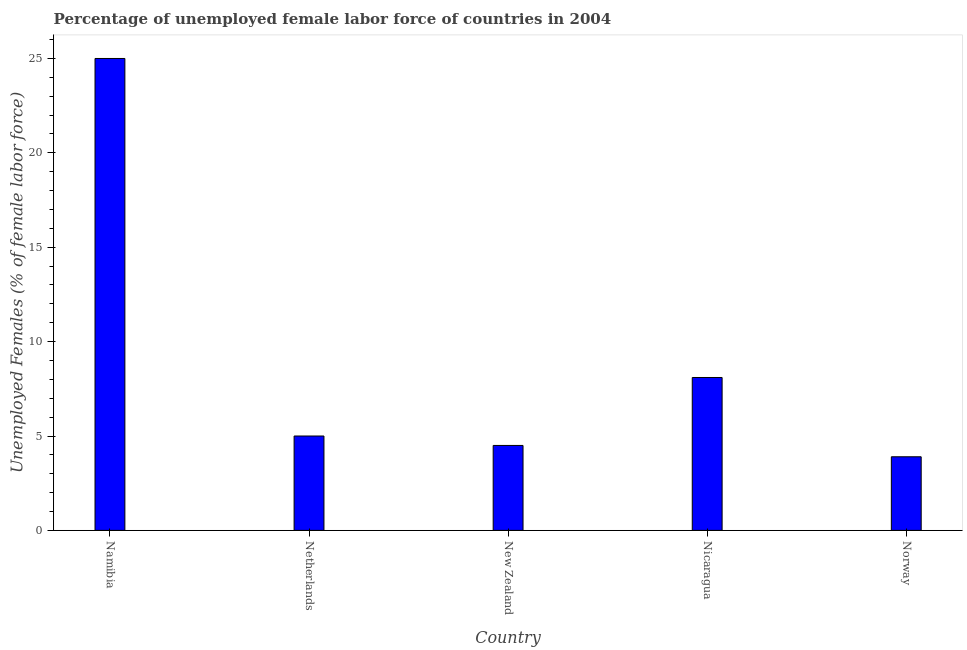Does the graph contain any zero values?
Make the answer very short. No. Does the graph contain grids?
Make the answer very short. No. What is the title of the graph?
Provide a short and direct response. Percentage of unemployed female labor force of countries in 2004. What is the label or title of the X-axis?
Keep it short and to the point. Country. What is the label or title of the Y-axis?
Give a very brief answer. Unemployed Females (% of female labor force). Across all countries, what is the minimum total unemployed female labour force?
Your answer should be very brief. 3.9. In which country was the total unemployed female labour force maximum?
Keep it short and to the point. Namibia. In which country was the total unemployed female labour force minimum?
Your answer should be compact. Norway. What is the sum of the total unemployed female labour force?
Provide a succinct answer. 46.5. What is the difference between the total unemployed female labour force in Netherlands and Norway?
Keep it short and to the point. 1.1. In how many countries, is the total unemployed female labour force greater than 11 %?
Your answer should be very brief. 1. What is the ratio of the total unemployed female labour force in Netherlands to that in Nicaragua?
Your answer should be compact. 0.62. Is the total unemployed female labour force in Netherlands less than that in New Zealand?
Your answer should be compact. No. What is the difference between the highest and the lowest total unemployed female labour force?
Your answer should be very brief. 21.1. In how many countries, is the total unemployed female labour force greater than the average total unemployed female labour force taken over all countries?
Your answer should be very brief. 1. How many bars are there?
Keep it short and to the point. 5. What is the Unemployed Females (% of female labor force) in Namibia?
Provide a succinct answer. 25. What is the Unemployed Females (% of female labor force) of Netherlands?
Your answer should be compact. 5. What is the Unemployed Females (% of female labor force) in New Zealand?
Make the answer very short. 4.5. What is the Unemployed Females (% of female labor force) in Nicaragua?
Offer a very short reply. 8.1. What is the Unemployed Females (% of female labor force) in Norway?
Provide a succinct answer. 3.9. What is the difference between the Unemployed Females (% of female labor force) in Namibia and Netherlands?
Provide a succinct answer. 20. What is the difference between the Unemployed Females (% of female labor force) in Namibia and Nicaragua?
Make the answer very short. 16.9. What is the difference between the Unemployed Females (% of female labor force) in Namibia and Norway?
Provide a succinct answer. 21.1. What is the difference between the Unemployed Females (% of female labor force) in Netherlands and Nicaragua?
Offer a terse response. -3.1. What is the difference between the Unemployed Females (% of female labor force) in Netherlands and Norway?
Provide a short and direct response. 1.1. What is the difference between the Unemployed Females (% of female labor force) in New Zealand and Nicaragua?
Keep it short and to the point. -3.6. What is the ratio of the Unemployed Females (% of female labor force) in Namibia to that in Netherlands?
Your answer should be compact. 5. What is the ratio of the Unemployed Females (% of female labor force) in Namibia to that in New Zealand?
Your answer should be very brief. 5.56. What is the ratio of the Unemployed Females (% of female labor force) in Namibia to that in Nicaragua?
Keep it short and to the point. 3.09. What is the ratio of the Unemployed Females (% of female labor force) in Namibia to that in Norway?
Your answer should be very brief. 6.41. What is the ratio of the Unemployed Females (% of female labor force) in Netherlands to that in New Zealand?
Your answer should be compact. 1.11. What is the ratio of the Unemployed Females (% of female labor force) in Netherlands to that in Nicaragua?
Offer a very short reply. 0.62. What is the ratio of the Unemployed Females (% of female labor force) in Netherlands to that in Norway?
Your response must be concise. 1.28. What is the ratio of the Unemployed Females (% of female labor force) in New Zealand to that in Nicaragua?
Ensure brevity in your answer.  0.56. What is the ratio of the Unemployed Females (% of female labor force) in New Zealand to that in Norway?
Provide a short and direct response. 1.15. What is the ratio of the Unemployed Females (% of female labor force) in Nicaragua to that in Norway?
Provide a short and direct response. 2.08. 